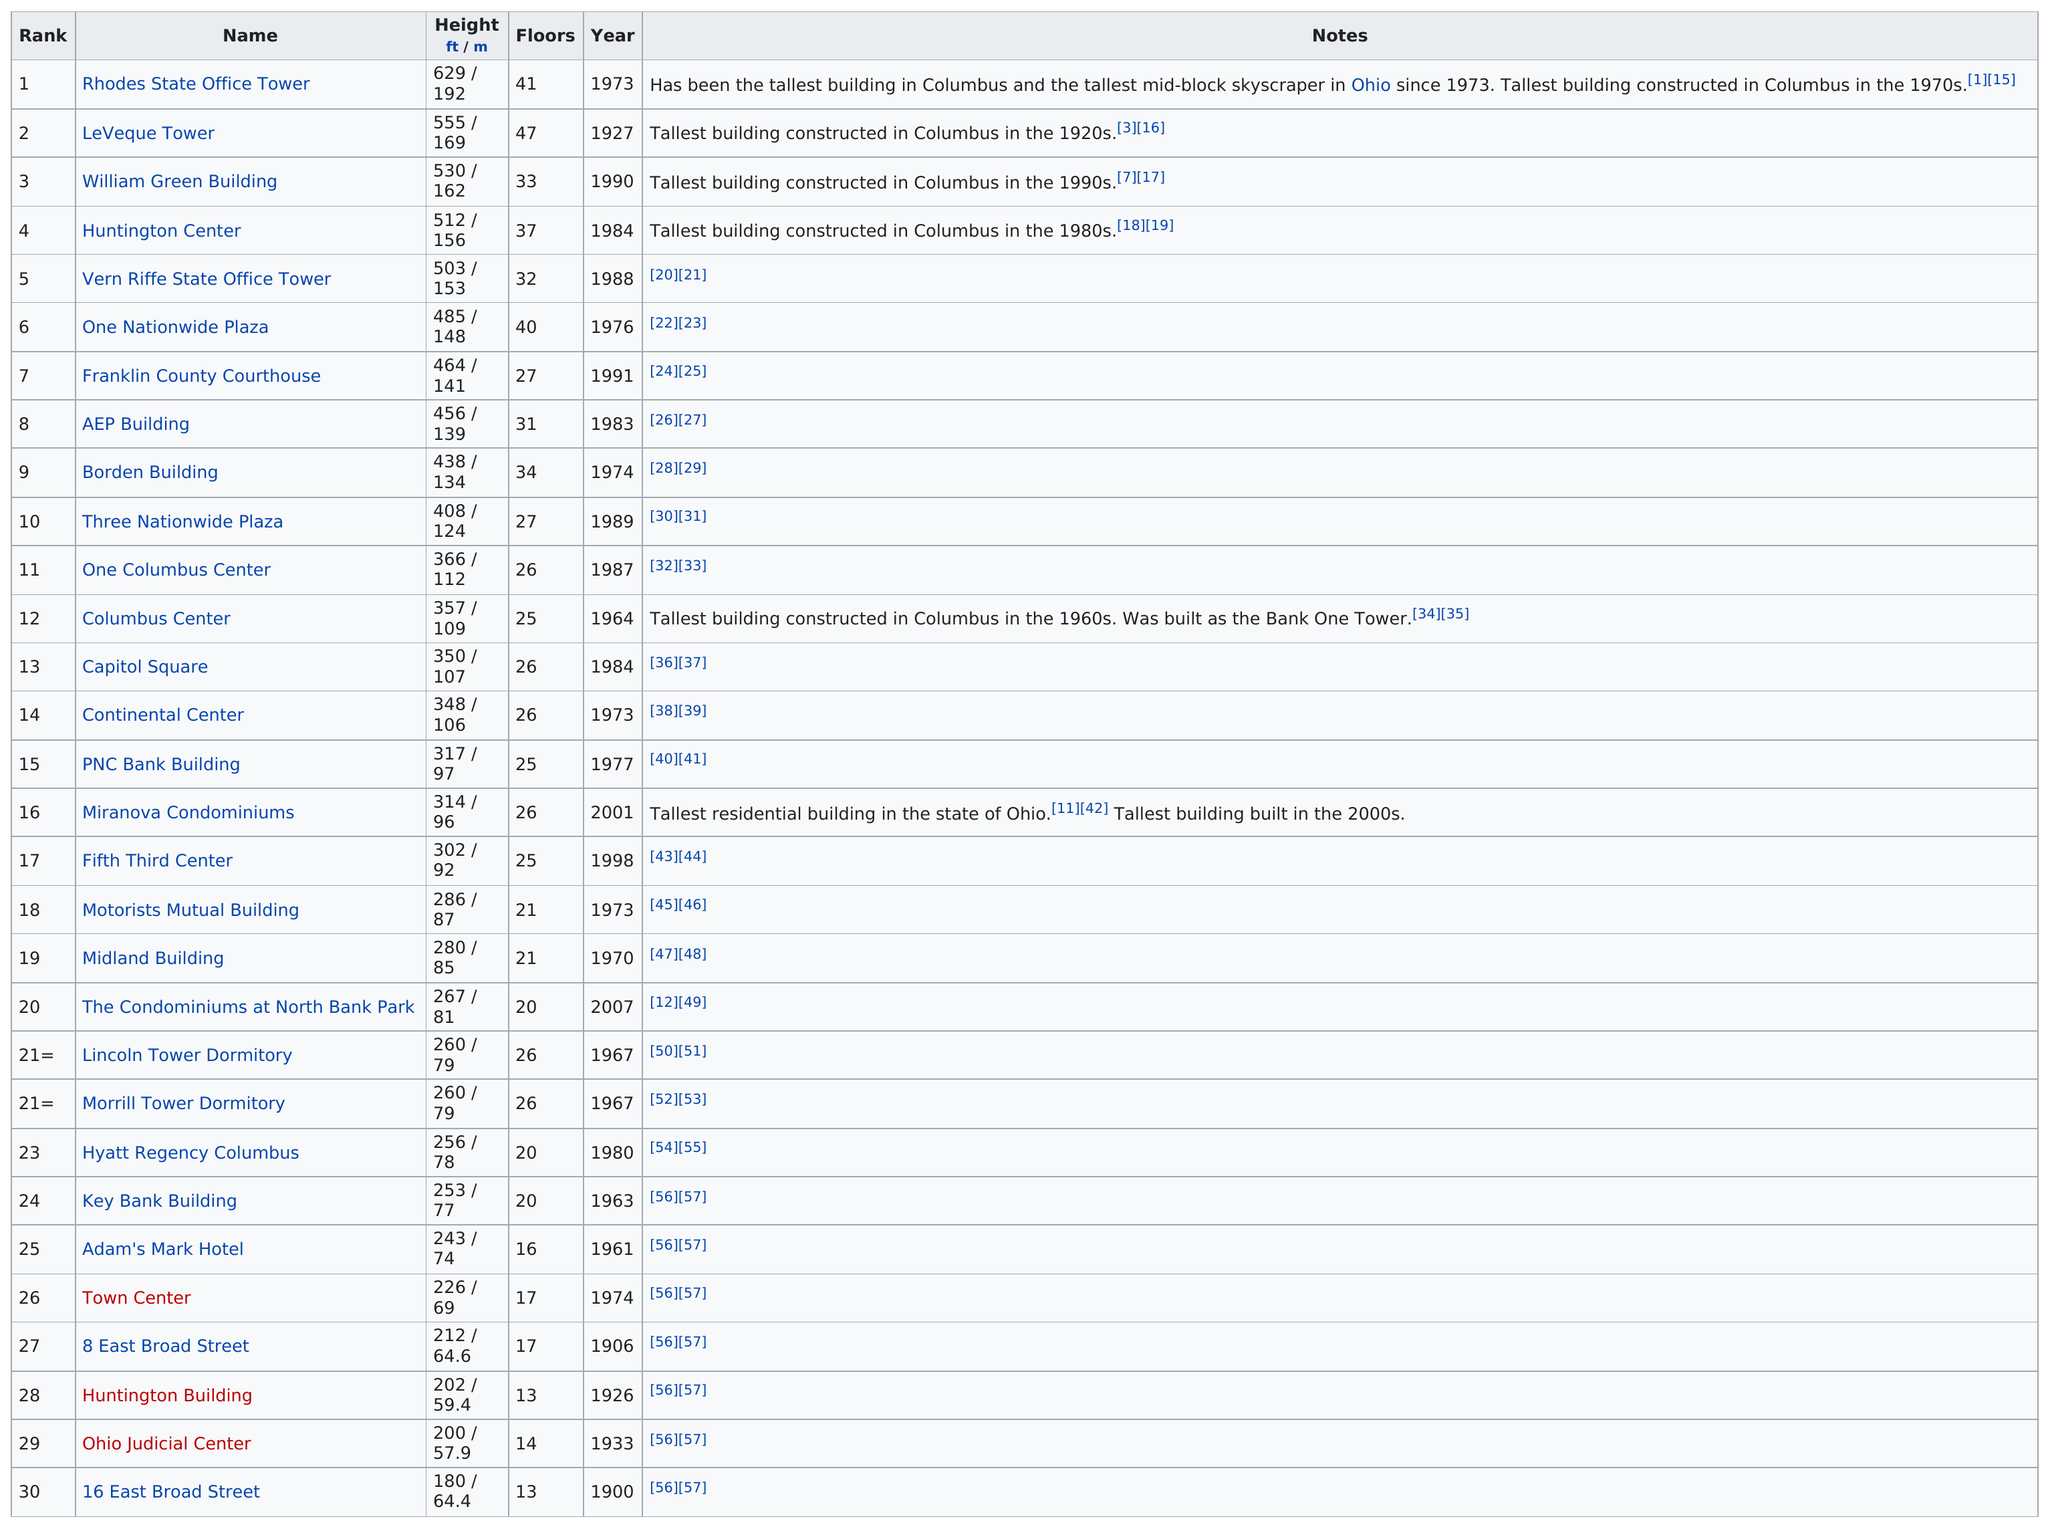Give some essential details in this illustration. The height difference between the two tallest buildings is 74 feet. The Capitol Square has 26 floors. The LeVeque Tower is taller than the Huntington Center. Of the buildings listed on this table, 8 of them are taller than 450 feet. The AEP Building is taller than the one at Columbus Center. 